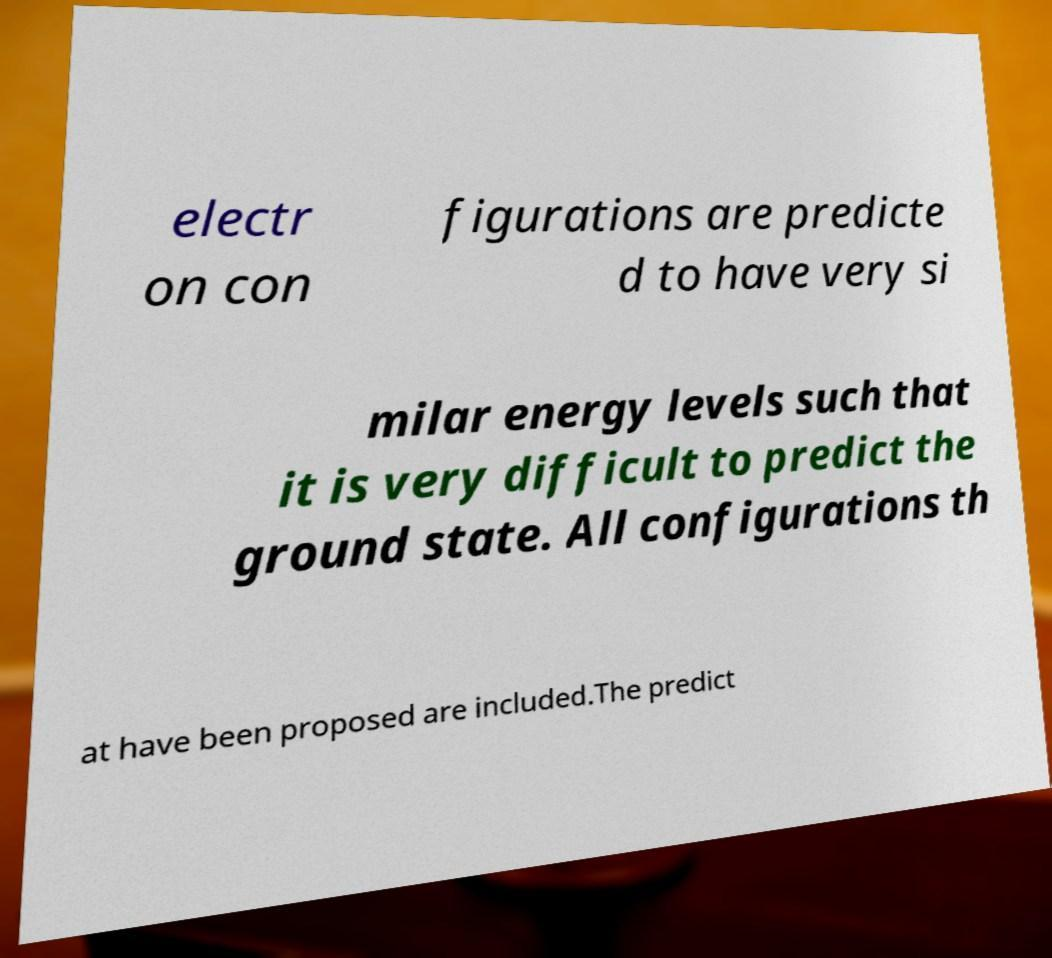Please identify and transcribe the text found in this image. electr on con figurations are predicte d to have very si milar energy levels such that it is very difficult to predict the ground state. All configurations th at have been proposed are included.The predict 